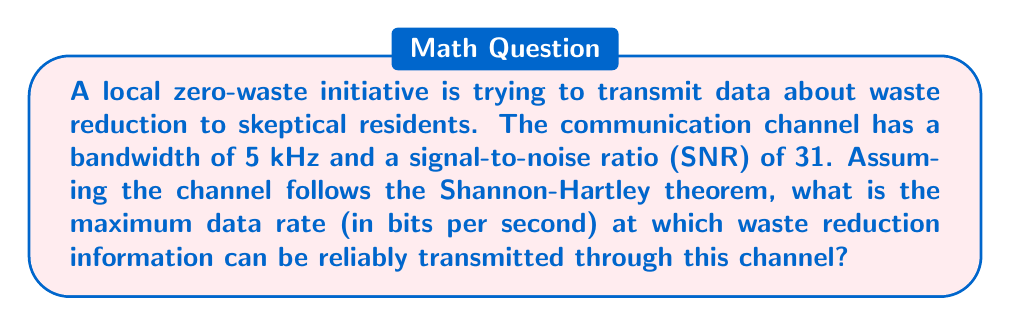Could you help me with this problem? To solve this problem, we need to use the Shannon-Hartley theorem, which gives the channel capacity for a communications channel subject to Gaussian noise. The theorem is expressed as:

$$C = B \log_2(1 + SNR)$$

Where:
$C$ is the channel capacity in bits per second
$B$ is the bandwidth of the channel in Hz
$SNR$ is the signal-to-noise ratio

Given:
- Bandwidth (B) = 5 kHz = 5000 Hz
- SNR = 31

Let's plug these values into the formula:

$$\begin{align*}
C &= 5000 \log_2(1 + 31) \\
&= 5000 \log_2(32) \\
&= 5000 \cdot 5 \\
&= 25000 \text{ bits per second}
\end{align*}$$

Note that $\log_2(32) = 5$ because $2^5 = 32$.

This result means that the zero-waste initiative can transmit up to 25,000 bits of waste reduction data per second through this channel without expecting significant errors in transmission.

For a skeptical sibling, it's worth noting that while this data rate might seem impressive, the practical impact of transmitting waste reduction information depends on how effectively this data can be translated into actionable steps and measurable results in reducing waste.
Answer: The maximum data rate at which waste reduction information can be reliably transmitted through this channel is 25,000 bits per second. 